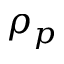<formula> <loc_0><loc_0><loc_500><loc_500>\rho _ { p }</formula> 